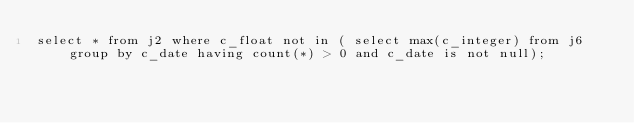<code> <loc_0><loc_0><loc_500><loc_500><_SQL_>select * from j2 where c_float not in ( select max(c_integer) from j6 group by c_date having count(*) > 0 and c_date is not null);
</code> 